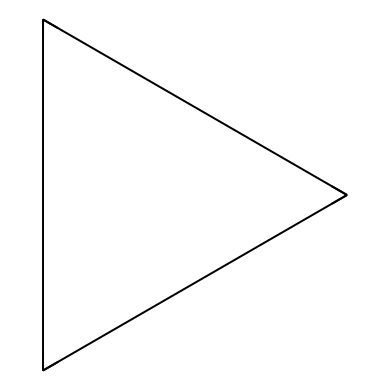What is the molecular formula of cyclopropane? The structure contains three carbon atoms (C) and six hydrogen atoms (H), which corresponds to the molecular formula C3H6.
Answer: C3H6 How many carbon atoms are present in cyclopropane? The visual representation clearly shows three carbon atoms arranged in a cyclic manner.
Answer: 3 What type of strain is present in cyclopropane's structure? Cyclopropane has angle strain due to the bond angles being significantly smaller than the typical tetrahedral angle of 109.5 degrees, leading to increased energy instability.
Answer: angle strain How many hydrogen atoms are attached to each carbon atom in cyclopropane? Each carbon atom in cyclopropane is bonded to two hydrogen atoms, totaling six hydrogen atoms for the three carbon atoms.
Answer: 2 What type of hydrocarbon is cyclopropane? Cyclopropane is classified as a cycloalkane because it consists only of carbon and hydrogen atoms in a ring structure with single bonds.
Answer: cycloalkane Why does cyclopropane have a higher reactivity compared to larger cycloalkanes? The ring strain due to its small size makes cyclopropane more reactive than larger cycloalkanes, which have less strain and more stable configurations.
Answer: higher reactivity 